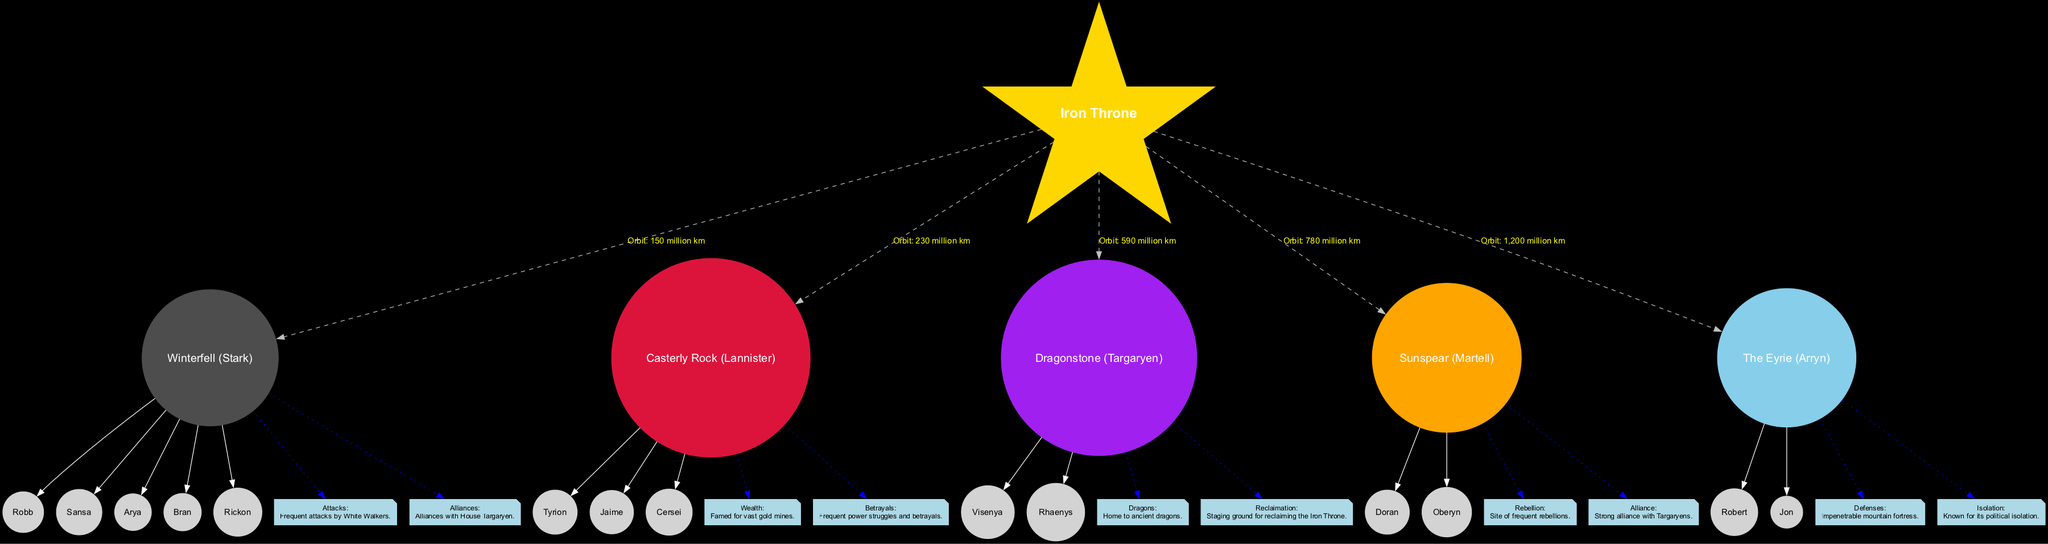What is the mass of Winterfell? The diagram indicates that the mass of Winterfell, which represents House Stark, is detailed in the provided information as "5.97 × 10^24 kg."
Answer: 5.97 × 10^24 kg How many moons does Casterly Rock have? According to the diagram, Casterly Rock (House Lannister) has three moons listed: Tyrion, Jaime, and Cersei. We count these to find the total number of moons associated with Casterly Rock.
Answer: 3 Which house is represented by the planet closest to the Iron Throne? The diagram specifies that Winterfell, representing House Stark, is at an orbit distance of 150 million km, making it the nearest planet to the Iron Throne at 150 million km.
Answer: Stark What key event is associated with Dragonstone? The diagram shows two key events associated with Dragonstone (House Targaryen): "Dragons" (Home to ancient dragons) and "Reclaimation" (Staging ground for reclaiming the Iron Throne). The answer can simply include one event or both based on the request.
Answer: Dragons Which house has the most moons? By examining the number of moons listed for each planet, Winterfell has five moons, Casterly Rock has three, Dragonstone has two, Sunspear has two, and The Eyrie has two. Thus, the house with the most moons is Winterfell.
Answer: Stark What is the orbit distance of The Eyrie? The diagram indicates that The Eyrie, representing House Arryn, has an orbit distance of "1,200 million km." This distance is listed directly in the information for The Eyrie.
Answer: 1,200 million km How many key events are associated with Sunspear? Sunspear (House Martell) has two key events listed in the diagram: "Rebellion" and "Alliance." Therefore, we can count these to answer how many events are associated with Sunspear.
Answer: 2 What color represents House Targaryen in the diagram? The diagram assigns a specific color to each house, and House Targaryen is represented by the color purple, which is indicated in the color coding section.
Answer: Purple 